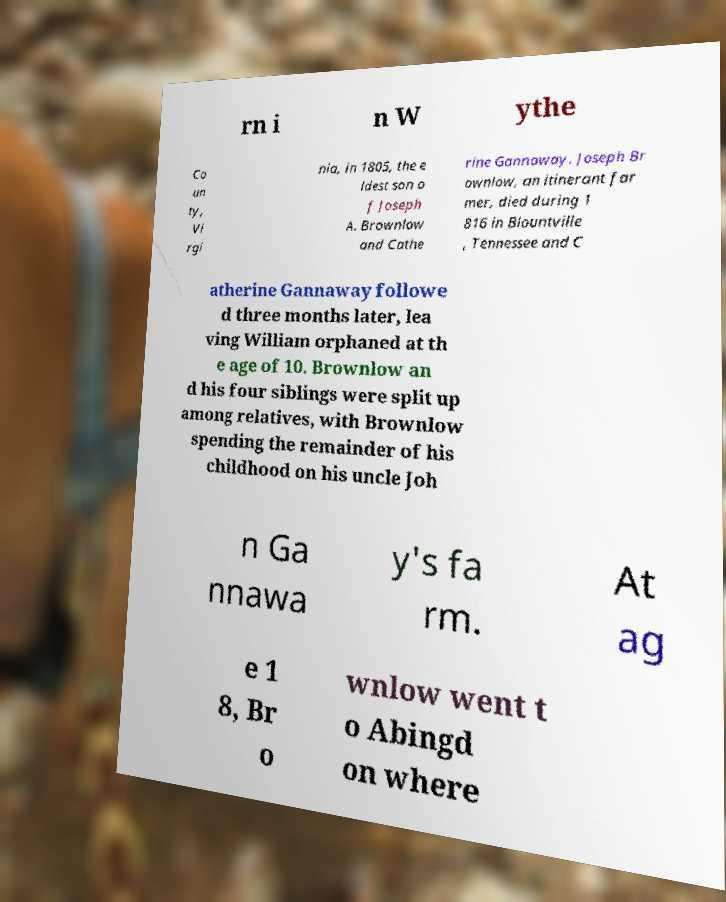Please identify and transcribe the text found in this image. rn i n W ythe Co un ty, Vi rgi nia, in 1805, the e ldest son o f Joseph A. Brownlow and Cathe rine Gannaway. Joseph Br ownlow, an itinerant far mer, died during 1 816 in Blountville , Tennessee and C atherine Gannaway followe d three months later, lea ving William orphaned at th e age of 10. Brownlow an d his four siblings were split up among relatives, with Brownlow spending the remainder of his childhood on his uncle Joh n Ga nnawa y's fa rm. At ag e 1 8, Br o wnlow went t o Abingd on where 